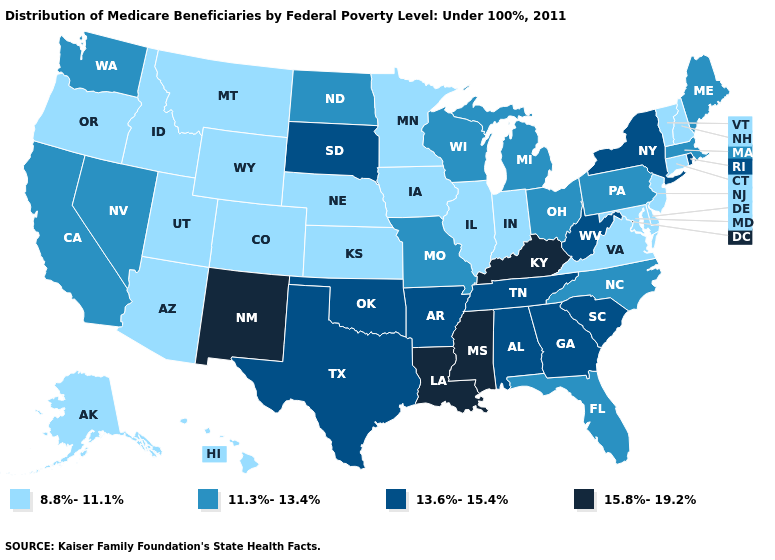What is the value of South Dakota?
Concise answer only. 13.6%-15.4%. Name the states that have a value in the range 11.3%-13.4%?
Concise answer only. California, Florida, Maine, Massachusetts, Michigan, Missouri, Nevada, North Carolina, North Dakota, Ohio, Pennsylvania, Washington, Wisconsin. How many symbols are there in the legend?
Quick response, please. 4. Which states have the lowest value in the USA?
Concise answer only. Alaska, Arizona, Colorado, Connecticut, Delaware, Hawaii, Idaho, Illinois, Indiana, Iowa, Kansas, Maryland, Minnesota, Montana, Nebraska, New Hampshire, New Jersey, Oregon, Utah, Vermont, Virginia, Wyoming. Which states have the lowest value in the West?
Keep it brief. Alaska, Arizona, Colorado, Hawaii, Idaho, Montana, Oregon, Utah, Wyoming. Which states have the highest value in the USA?
Give a very brief answer. Kentucky, Louisiana, Mississippi, New Mexico. Name the states that have a value in the range 8.8%-11.1%?
Concise answer only. Alaska, Arizona, Colorado, Connecticut, Delaware, Hawaii, Idaho, Illinois, Indiana, Iowa, Kansas, Maryland, Minnesota, Montana, Nebraska, New Hampshire, New Jersey, Oregon, Utah, Vermont, Virginia, Wyoming. Name the states that have a value in the range 11.3%-13.4%?
Give a very brief answer. California, Florida, Maine, Massachusetts, Michigan, Missouri, Nevada, North Carolina, North Dakota, Ohio, Pennsylvania, Washington, Wisconsin. Does South Carolina have a lower value than North Dakota?
Concise answer only. No. Does Ohio have the same value as New Hampshire?
Write a very short answer. No. Does the first symbol in the legend represent the smallest category?
Quick response, please. Yes. What is the value of New Mexico?
Give a very brief answer. 15.8%-19.2%. Does Connecticut have a higher value than Idaho?
Write a very short answer. No. Name the states that have a value in the range 11.3%-13.4%?
Answer briefly. California, Florida, Maine, Massachusetts, Michigan, Missouri, Nevada, North Carolina, North Dakota, Ohio, Pennsylvania, Washington, Wisconsin. Name the states that have a value in the range 15.8%-19.2%?
Concise answer only. Kentucky, Louisiana, Mississippi, New Mexico. 